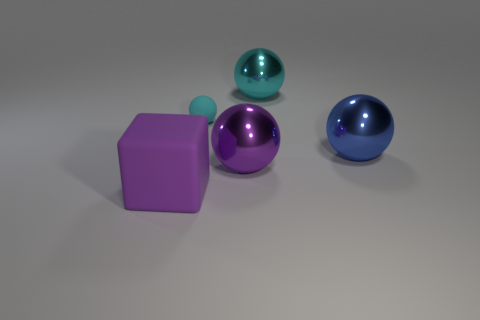Are there any other things that have the same size as the cyan rubber ball?
Your response must be concise. No. What number of other things are made of the same material as the big blue ball?
Offer a very short reply. 2. Do the purple object that is left of the small cyan matte thing and the tiny sphere have the same material?
Make the answer very short. Yes. Are there more tiny balls in front of the big purple rubber block than metallic objects to the left of the big blue metal thing?
Your answer should be very brief. No. What number of things are either objects that are behind the purple matte cube or blocks?
Provide a succinct answer. 5. There is a tiny thing that is the same material as the big purple cube; what shape is it?
Your answer should be compact. Sphere. Is there anything else that is the same shape as the large matte object?
Keep it short and to the point. No. What is the color of the large shiny sphere that is both to the left of the large blue object and in front of the cyan rubber ball?
Offer a terse response. Purple. What number of balls are big purple shiny things or tiny cyan rubber objects?
Your answer should be very brief. 2. How many purple metal balls have the same size as the purple metal object?
Provide a short and direct response. 0. 